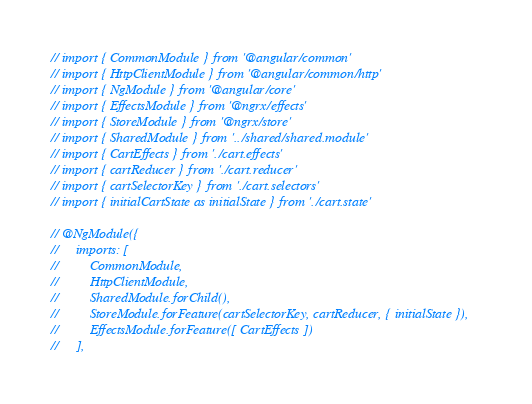<code> <loc_0><loc_0><loc_500><loc_500><_TypeScript_>// import { CommonModule } from '@angular/common'
// import { HttpClientModule } from '@angular/common/http'
// import { NgModule } from '@angular/core'
// import { EffectsModule } from '@ngrx/effects'
// import { StoreModule } from '@ngrx/store'
// import { SharedModule } from '../shared/shared.module'
// import { CartEffects } from './cart.effects'
// import { cartReducer } from './cart.reducer'
// import { cartSelectorKey } from './cart.selectors'
// import { initialCartState as initialState } from './cart.state'

// @NgModule({
//     imports: [
//         CommonModule,
//         HttpClientModule,
//         SharedModule.forChild(),
//         StoreModule.forFeature(cartSelectorKey, cartReducer, { initialState }),
//         EffectsModule.forFeature([ CartEffects ])
//     ],</code> 